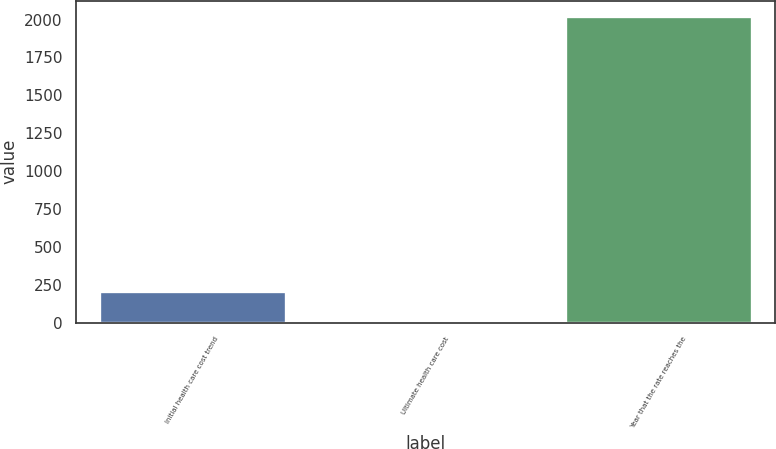<chart> <loc_0><loc_0><loc_500><loc_500><bar_chart><fcel>Initial health care cost trend<fcel>Ultimate health care cost<fcel>Year that the rate reaches the<nl><fcel>206.45<fcel>4.5<fcel>2024<nl></chart> 